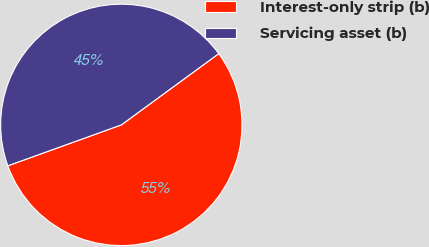<chart> <loc_0><loc_0><loc_500><loc_500><pie_chart><fcel>Interest-only strip (b)<fcel>Servicing asset (b)<nl><fcel>54.55%<fcel>45.45%<nl></chart> 